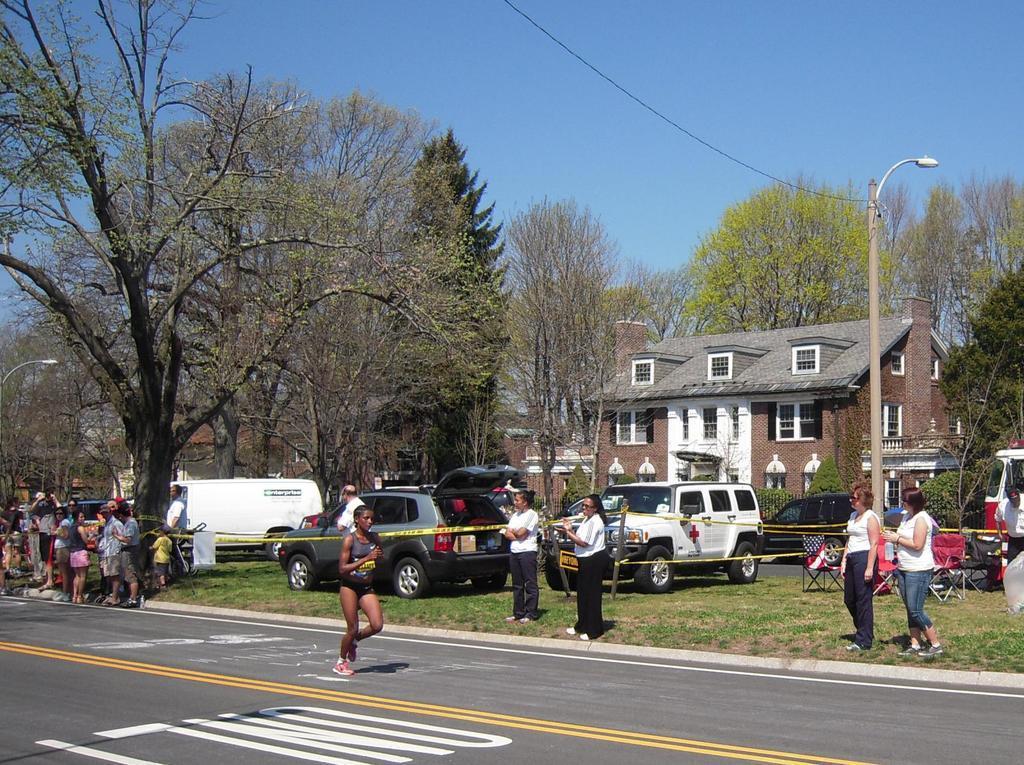Describe this image in one or two sentences. In this image I can see group of people standing, in front the person is running on the road. Background I can see few vehicles, a building in brown color, trees in green color and a light pole and the sky is in blue color. 